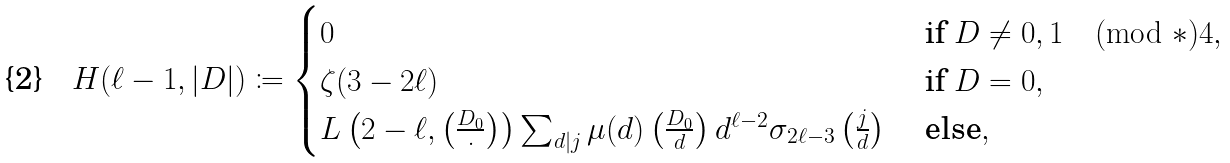<formula> <loc_0><loc_0><loc_500><loc_500>H ( \ell - 1 , | D | ) \coloneqq \begin{cases} 0 & \text { if } D \neq 0 , 1 \pmod { * } { 4 } , \\ \zeta ( 3 - 2 \ell ) & \text { if } D = 0 , \\ L \left ( 2 - \ell , \left ( \frac { D _ { 0 } } { \cdot } \right ) \right ) \sum _ { d | j } \mu ( d ) \left ( \frac { D _ { 0 } } { d } \right ) d ^ { \ell - 2 } \sigma _ { 2 \ell - 3 } \left ( \frac { j } { d } \right ) & \text { else} , \end{cases}</formula> 